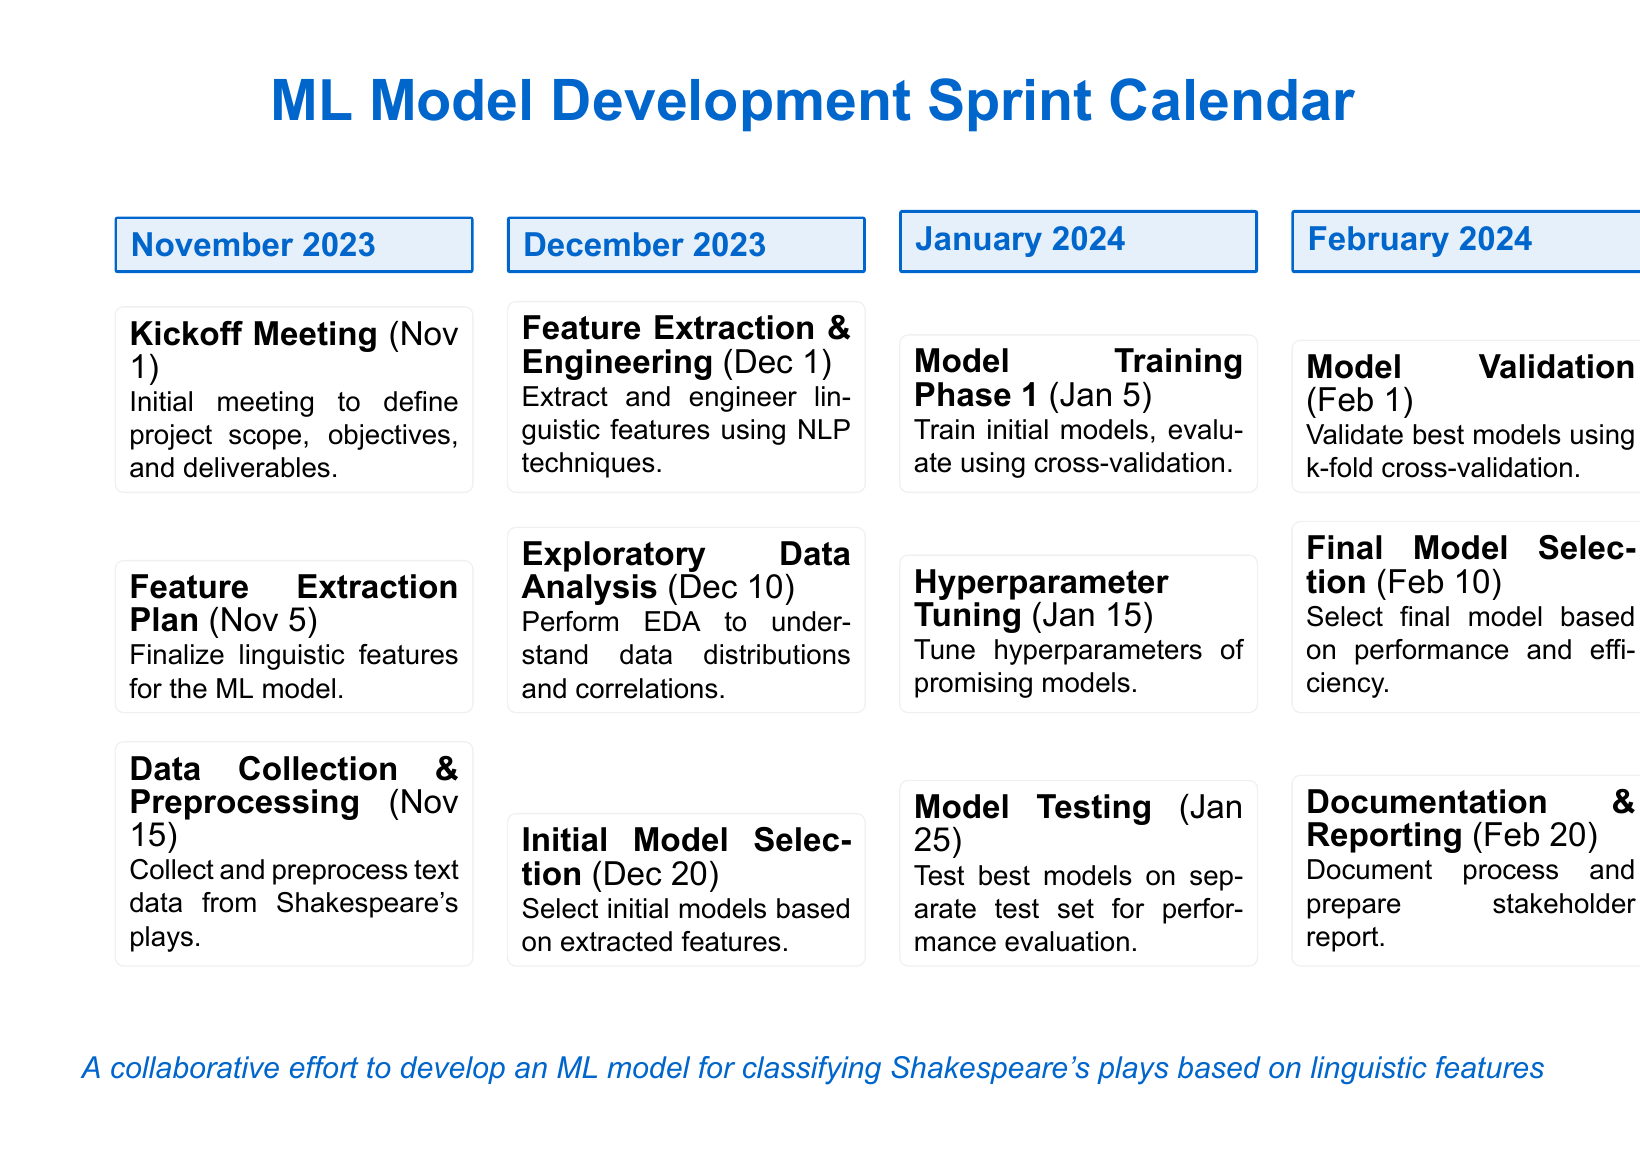What is the kickoff meeting date? The kickoff meeting is scheduled for November 1, 2023.
Answer: November 1 When is the feature extraction and engineering milestone? This milestone is set for December 1, 2023.
Answer: December 1 What is the final model selection date? The final model selection is on February 10, 2024.
Answer: February 10 How many major milestones are there in January? There are three milestones in January: Model Training Phase 1, Hyperparameter Tuning, and Model Testing.
Answer: Three Which phase involves collecting and preprocessing text data? The Data Collection & Preprocessing phase occurs on November 15, 2023.
Answer: Data Collection & Preprocessing What is the purpose of the initial model selection milestone? It involves selecting initial models based on extracted features.
Answer: Select initial models When will documentation and reporting be completed? Documentation and reporting are scheduled for February 20, 2024.
Answer: February 20 